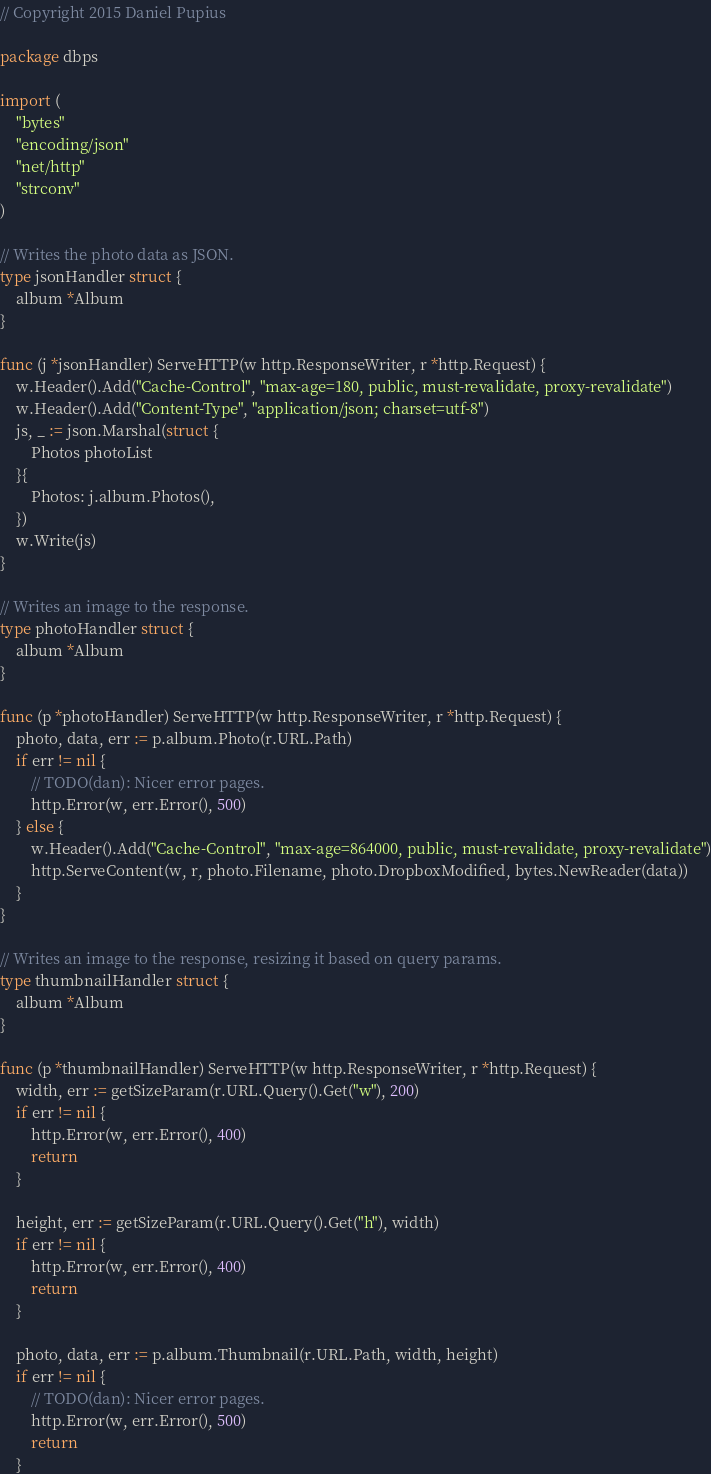Convert code to text. <code><loc_0><loc_0><loc_500><loc_500><_Go_>// Copyright 2015 Daniel Pupius

package dbps

import (
	"bytes"
	"encoding/json"
	"net/http"
	"strconv"
)

// Writes the photo data as JSON.
type jsonHandler struct {
	album *Album
}

func (j *jsonHandler) ServeHTTP(w http.ResponseWriter, r *http.Request) {
	w.Header().Add("Cache-Control", "max-age=180, public, must-revalidate, proxy-revalidate")
	w.Header().Add("Content-Type", "application/json; charset=utf-8")
	js, _ := json.Marshal(struct {
		Photos photoList
	}{
		Photos: j.album.Photos(),
	})
	w.Write(js)
}

// Writes an image to the response.
type photoHandler struct {
	album *Album
}

func (p *photoHandler) ServeHTTP(w http.ResponseWriter, r *http.Request) {
	photo, data, err := p.album.Photo(r.URL.Path)
	if err != nil {
		// TODO(dan): Nicer error pages.
		http.Error(w, err.Error(), 500)
	} else {
		w.Header().Add("Cache-Control", "max-age=864000, public, must-revalidate, proxy-revalidate")
		http.ServeContent(w, r, photo.Filename, photo.DropboxModified, bytes.NewReader(data))
	}
}

// Writes an image to the response, resizing it based on query params.
type thumbnailHandler struct {
	album *Album
}

func (p *thumbnailHandler) ServeHTTP(w http.ResponseWriter, r *http.Request) {
	width, err := getSizeParam(r.URL.Query().Get("w"), 200)
	if err != nil {
		http.Error(w, err.Error(), 400)
		return
	}

	height, err := getSizeParam(r.URL.Query().Get("h"), width)
	if err != nil {
		http.Error(w, err.Error(), 400)
		return
	}

	photo, data, err := p.album.Thumbnail(r.URL.Path, width, height)
	if err != nil {
		// TODO(dan): Nicer error pages.
		http.Error(w, err.Error(), 500)
		return
	}
</code> 